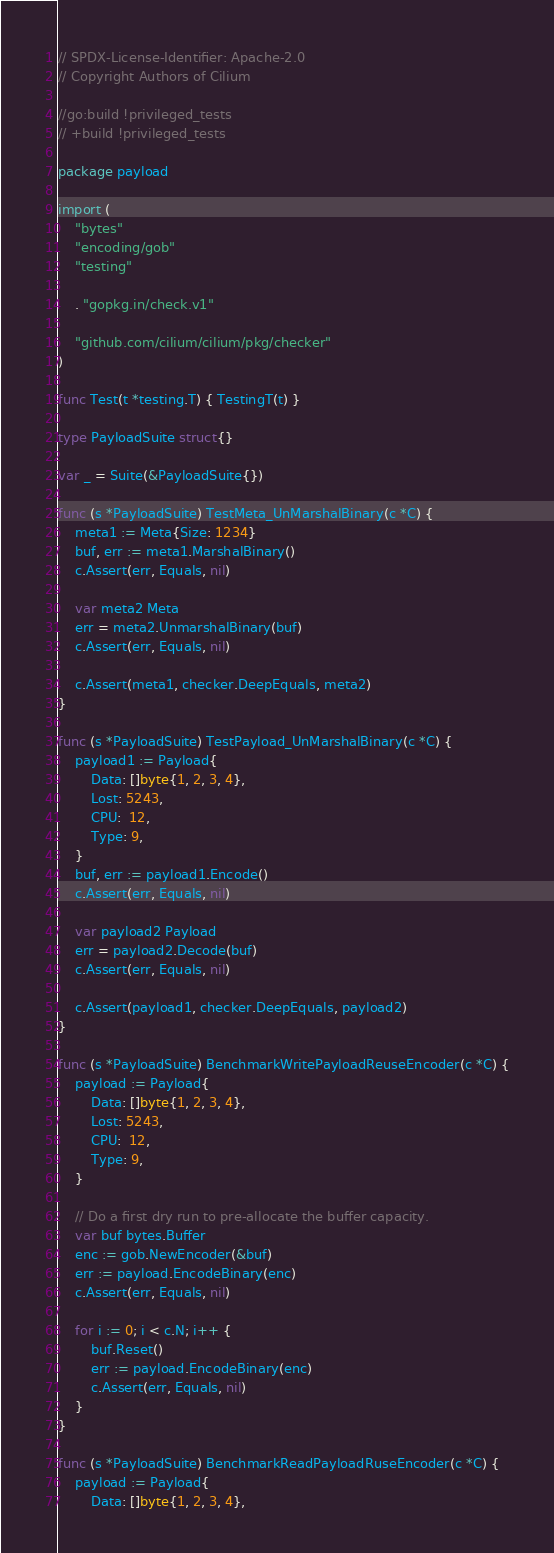Convert code to text. <code><loc_0><loc_0><loc_500><loc_500><_Go_>// SPDX-License-Identifier: Apache-2.0
// Copyright Authors of Cilium

//go:build !privileged_tests
// +build !privileged_tests

package payload

import (
	"bytes"
	"encoding/gob"
	"testing"

	. "gopkg.in/check.v1"

	"github.com/cilium/cilium/pkg/checker"
)

func Test(t *testing.T) { TestingT(t) }

type PayloadSuite struct{}

var _ = Suite(&PayloadSuite{})

func (s *PayloadSuite) TestMeta_UnMarshalBinary(c *C) {
	meta1 := Meta{Size: 1234}
	buf, err := meta1.MarshalBinary()
	c.Assert(err, Equals, nil)

	var meta2 Meta
	err = meta2.UnmarshalBinary(buf)
	c.Assert(err, Equals, nil)

	c.Assert(meta1, checker.DeepEquals, meta2)
}

func (s *PayloadSuite) TestPayload_UnMarshalBinary(c *C) {
	payload1 := Payload{
		Data: []byte{1, 2, 3, 4},
		Lost: 5243,
		CPU:  12,
		Type: 9,
	}
	buf, err := payload1.Encode()
	c.Assert(err, Equals, nil)

	var payload2 Payload
	err = payload2.Decode(buf)
	c.Assert(err, Equals, nil)

	c.Assert(payload1, checker.DeepEquals, payload2)
}

func (s *PayloadSuite) BenchmarkWritePayloadReuseEncoder(c *C) {
	payload := Payload{
		Data: []byte{1, 2, 3, 4},
		Lost: 5243,
		CPU:  12,
		Type: 9,
	}

	// Do a first dry run to pre-allocate the buffer capacity.
	var buf bytes.Buffer
	enc := gob.NewEncoder(&buf)
	err := payload.EncodeBinary(enc)
	c.Assert(err, Equals, nil)

	for i := 0; i < c.N; i++ {
		buf.Reset()
		err := payload.EncodeBinary(enc)
		c.Assert(err, Equals, nil)
	}
}

func (s *PayloadSuite) BenchmarkReadPayloadRuseEncoder(c *C) {
	payload := Payload{
		Data: []byte{1, 2, 3, 4},</code> 